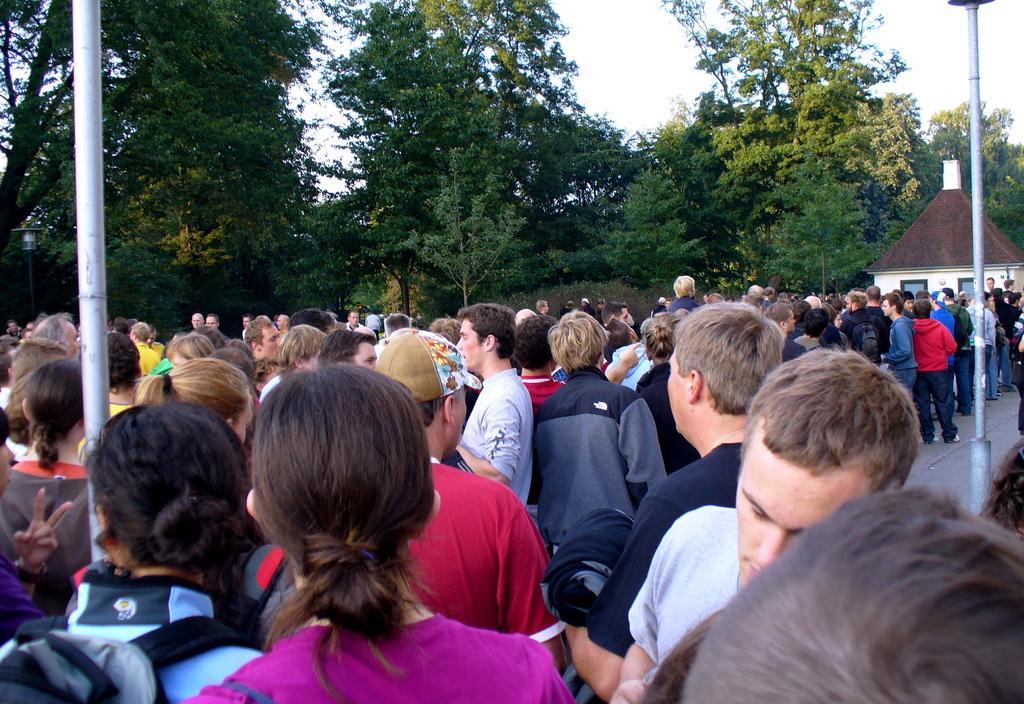In one or two sentences, can you explain what this image depicts? In the image we can see there are many people standing, wearing clothes and some of them are carrying a bag on their back. This is a pole, footpath, house, trees and a white sky. 